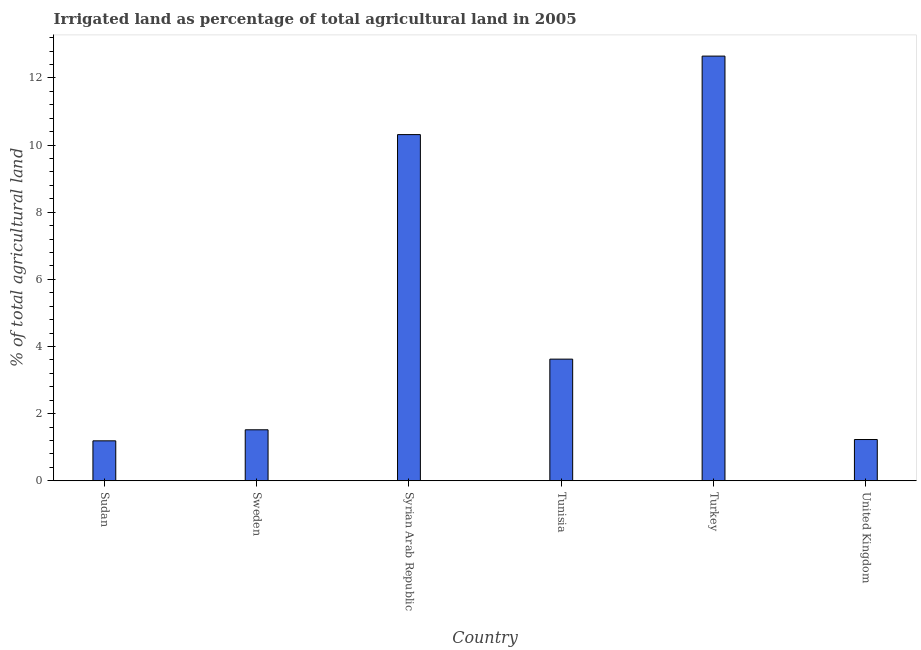What is the title of the graph?
Offer a terse response. Irrigated land as percentage of total agricultural land in 2005. What is the label or title of the Y-axis?
Your response must be concise. % of total agricultural land. What is the percentage of agricultural irrigated land in Sweden?
Ensure brevity in your answer.  1.52. Across all countries, what is the maximum percentage of agricultural irrigated land?
Make the answer very short. 12.65. Across all countries, what is the minimum percentage of agricultural irrigated land?
Provide a succinct answer. 1.19. In which country was the percentage of agricultural irrigated land minimum?
Provide a succinct answer. Sudan. What is the sum of the percentage of agricultural irrigated land?
Your response must be concise. 30.52. What is the difference between the percentage of agricultural irrigated land in Tunisia and United Kingdom?
Your answer should be compact. 2.4. What is the average percentage of agricultural irrigated land per country?
Offer a terse response. 5.09. What is the median percentage of agricultural irrigated land?
Provide a short and direct response. 2.57. In how many countries, is the percentage of agricultural irrigated land greater than 2.8 %?
Your answer should be very brief. 3. What is the ratio of the percentage of agricultural irrigated land in Sweden to that in Tunisia?
Offer a very short reply. 0.42. Is the difference between the percentage of agricultural irrigated land in Sudan and United Kingdom greater than the difference between any two countries?
Give a very brief answer. No. What is the difference between the highest and the second highest percentage of agricultural irrigated land?
Make the answer very short. 2.34. Is the sum of the percentage of agricultural irrigated land in Sweden and Turkey greater than the maximum percentage of agricultural irrigated land across all countries?
Provide a short and direct response. Yes. What is the difference between the highest and the lowest percentage of agricultural irrigated land?
Your response must be concise. 11.46. In how many countries, is the percentage of agricultural irrigated land greater than the average percentage of agricultural irrigated land taken over all countries?
Provide a succinct answer. 2. How many bars are there?
Provide a short and direct response. 6. What is the difference between two consecutive major ticks on the Y-axis?
Ensure brevity in your answer.  2. Are the values on the major ticks of Y-axis written in scientific E-notation?
Your response must be concise. No. What is the % of total agricultural land of Sudan?
Give a very brief answer. 1.19. What is the % of total agricultural land of Sweden?
Make the answer very short. 1.52. What is the % of total agricultural land of Syrian Arab Republic?
Offer a very short reply. 10.31. What is the % of total agricultural land in Tunisia?
Your answer should be compact. 3.62. What is the % of total agricultural land in Turkey?
Ensure brevity in your answer.  12.65. What is the % of total agricultural land in United Kingdom?
Your answer should be compact. 1.23. What is the difference between the % of total agricultural land in Sudan and Sweden?
Make the answer very short. -0.33. What is the difference between the % of total agricultural land in Sudan and Syrian Arab Republic?
Ensure brevity in your answer.  -9.12. What is the difference between the % of total agricultural land in Sudan and Tunisia?
Give a very brief answer. -2.43. What is the difference between the % of total agricultural land in Sudan and Turkey?
Your answer should be compact. -11.46. What is the difference between the % of total agricultural land in Sudan and United Kingdom?
Offer a very short reply. -0.04. What is the difference between the % of total agricultural land in Sweden and Syrian Arab Republic?
Offer a terse response. -8.79. What is the difference between the % of total agricultural land in Sweden and Tunisia?
Provide a short and direct response. -2.1. What is the difference between the % of total agricultural land in Sweden and Turkey?
Provide a succinct answer. -11.13. What is the difference between the % of total agricultural land in Sweden and United Kingdom?
Keep it short and to the point. 0.29. What is the difference between the % of total agricultural land in Syrian Arab Republic and Tunisia?
Keep it short and to the point. 6.69. What is the difference between the % of total agricultural land in Syrian Arab Republic and Turkey?
Your answer should be very brief. -2.34. What is the difference between the % of total agricultural land in Syrian Arab Republic and United Kingdom?
Offer a very short reply. 9.08. What is the difference between the % of total agricultural land in Tunisia and Turkey?
Give a very brief answer. -9.03. What is the difference between the % of total agricultural land in Tunisia and United Kingdom?
Keep it short and to the point. 2.39. What is the difference between the % of total agricultural land in Turkey and United Kingdom?
Offer a terse response. 11.42. What is the ratio of the % of total agricultural land in Sudan to that in Sweden?
Ensure brevity in your answer.  0.78. What is the ratio of the % of total agricultural land in Sudan to that in Syrian Arab Republic?
Provide a short and direct response. 0.12. What is the ratio of the % of total agricultural land in Sudan to that in Tunisia?
Provide a short and direct response. 0.33. What is the ratio of the % of total agricultural land in Sudan to that in Turkey?
Your answer should be very brief. 0.09. What is the ratio of the % of total agricultural land in Sweden to that in Syrian Arab Republic?
Provide a short and direct response. 0.15. What is the ratio of the % of total agricultural land in Sweden to that in Tunisia?
Make the answer very short. 0.42. What is the ratio of the % of total agricultural land in Sweden to that in Turkey?
Keep it short and to the point. 0.12. What is the ratio of the % of total agricultural land in Sweden to that in United Kingdom?
Keep it short and to the point. 1.24. What is the ratio of the % of total agricultural land in Syrian Arab Republic to that in Tunisia?
Offer a very short reply. 2.85. What is the ratio of the % of total agricultural land in Syrian Arab Republic to that in Turkey?
Give a very brief answer. 0.81. What is the ratio of the % of total agricultural land in Syrian Arab Republic to that in United Kingdom?
Keep it short and to the point. 8.39. What is the ratio of the % of total agricultural land in Tunisia to that in Turkey?
Ensure brevity in your answer.  0.29. What is the ratio of the % of total agricultural land in Tunisia to that in United Kingdom?
Provide a short and direct response. 2.95. What is the ratio of the % of total agricultural land in Turkey to that in United Kingdom?
Provide a succinct answer. 10.29. 